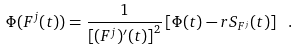Convert formula to latex. <formula><loc_0><loc_0><loc_500><loc_500>\Phi ( F ^ { j } ( t ) ) = \frac { 1 } { \left [ ( F ^ { j } ) ^ { \prime } ( t ) \right ] ^ { 2 } } \left [ \Phi ( t ) - r S _ { F ^ { j } } ( t ) \right ] \ .</formula> 